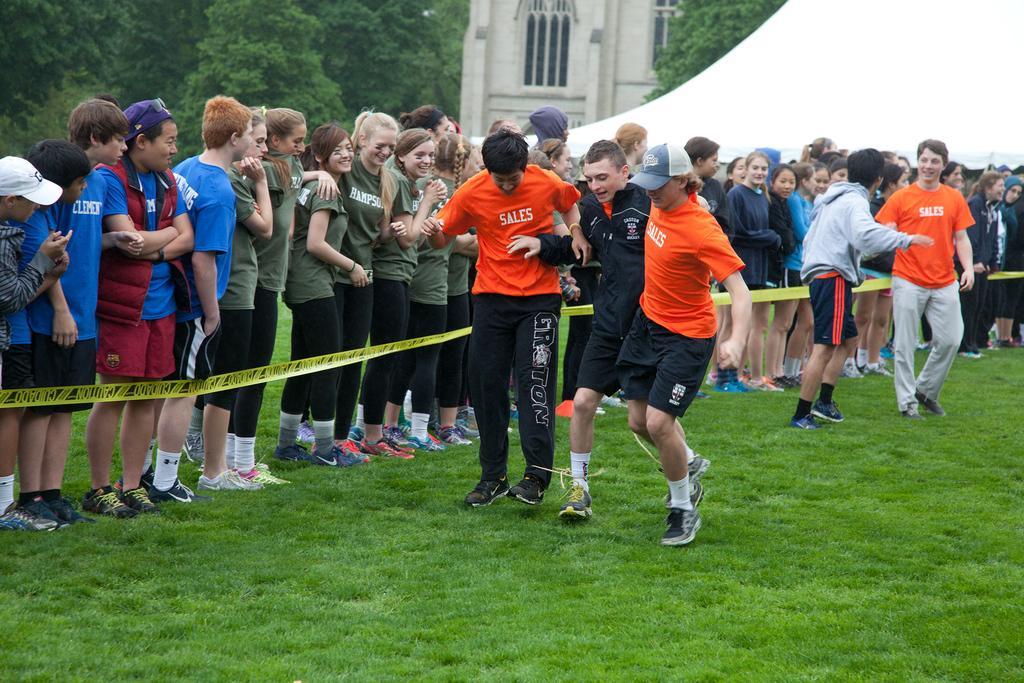Please provide a concise description of this image. In this picture there are three boys in the center of the image, on the grassland and there are other people those who are standing in series behind them and there is a building at the top side of the image and there are trees in the background area of the image. 